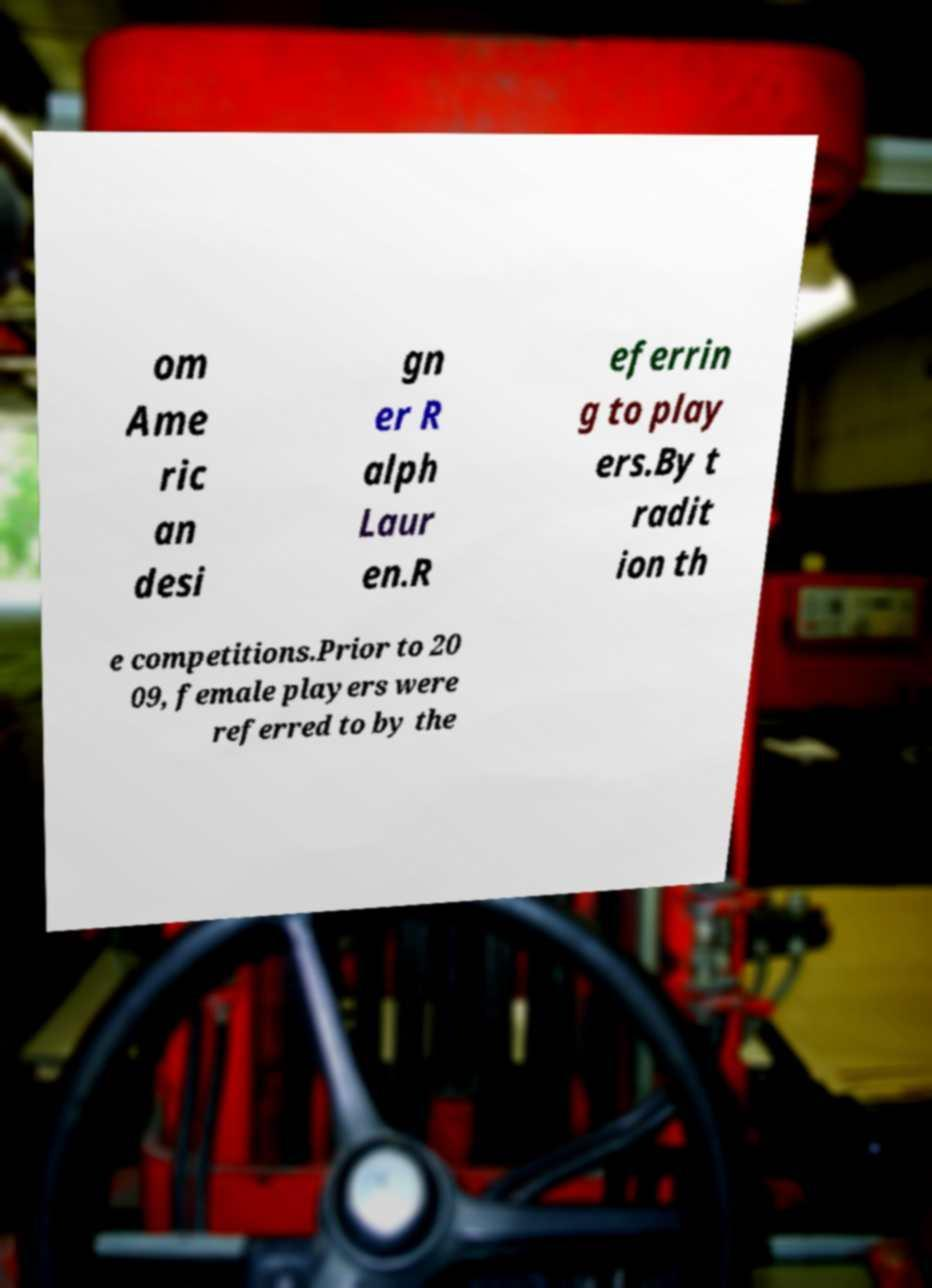What messages or text are displayed in this image? I need them in a readable, typed format. om Ame ric an desi gn er R alph Laur en.R eferrin g to play ers.By t radit ion th e competitions.Prior to 20 09, female players were referred to by the 